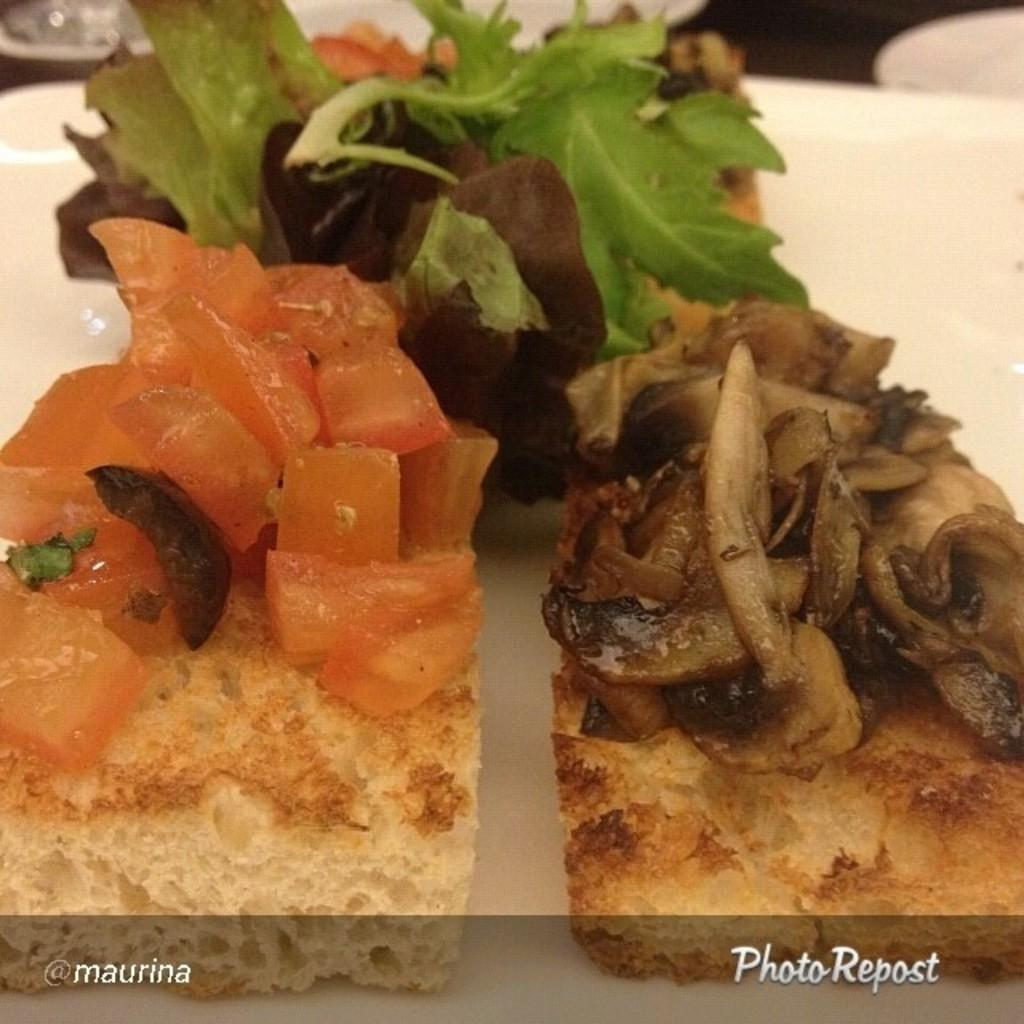What types of food can be seen in the image? There are eatables in the image, including green leafy vegetables. What color is the table in the image? The table is white. How would you describe the color scheme of the background in the image? The background is in white and black color. Is there any indication that the image has been altered or edited? The image might be edited, but there is no definitive way to determine that from the provided facts. What time is displayed on the clock in the image? There is no clock present in the image, so it is not possible to determine the time. 